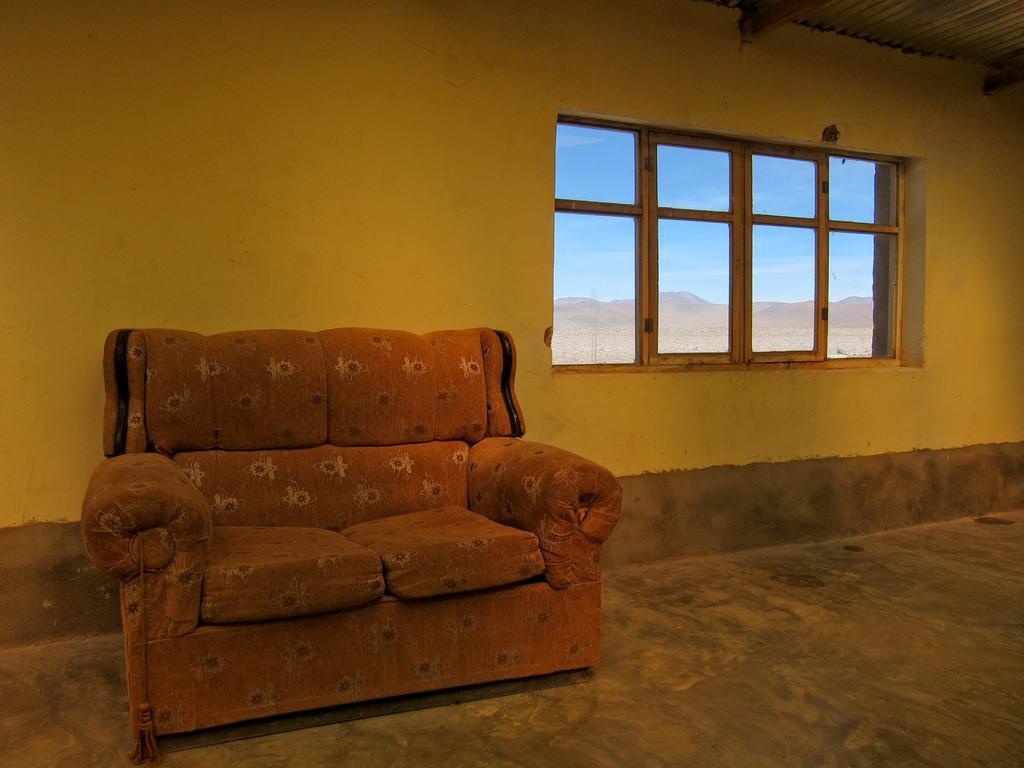How would you summarize this image in a sentence or two? In this image, there is a sofa in the left side. In the right side middle of the image, there is a window, through which mountains and sky blue in color is visible. The roof top is made up of tin shed. The background wall is visible which is light orange in color. The picture is taken inside the house. 